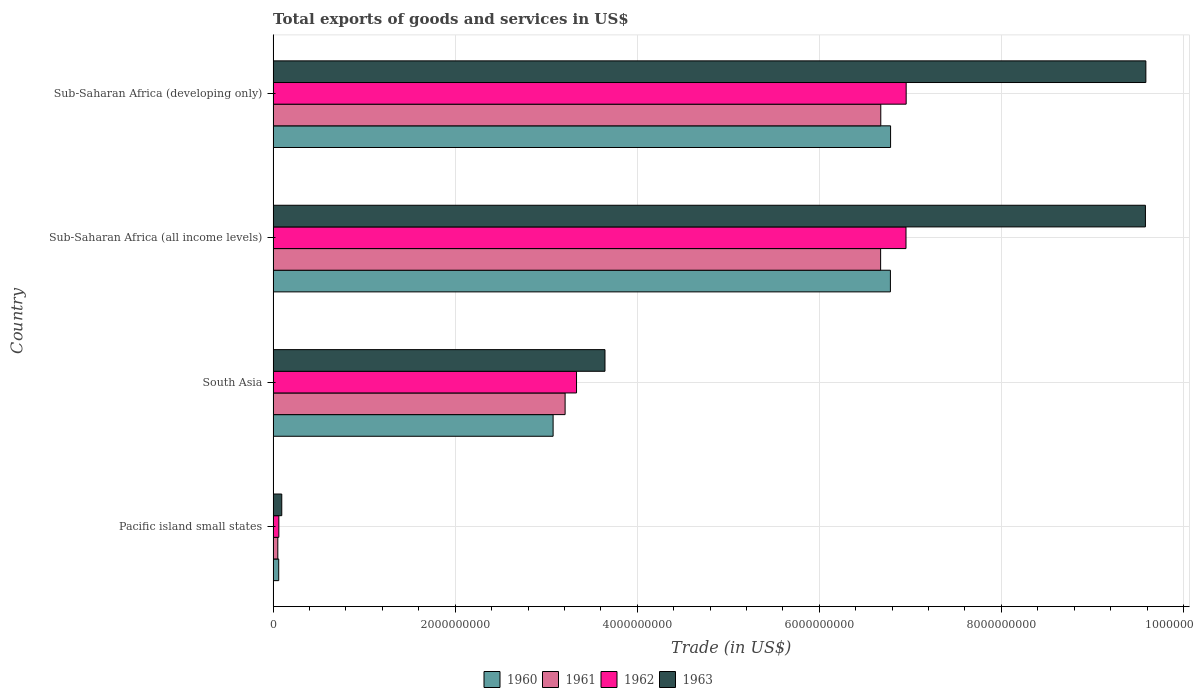How many different coloured bars are there?
Offer a terse response. 4. Are the number of bars per tick equal to the number of legend labels?
Make the answer very short. Yes. What is the label of the 1st group of bars from the top?
Provide a short and direct response. Sub-Saharan Africa (developing only). What is the total exports of goods and services in 1960 in Pacific island small states?
Offer a terse response. 6.15e+07. Across all countries, what is the maximum total exports of goods and services in 1963?
Your answer should be very brief. 9.59e+09. Across all countries, what is the minimum total exports of goods and services in 1960?
Keep it short and to the point. 6.15e+07. In which country was the total exports of goods and services in 1961 maximum?
Offer a terse response. Sub-Saharan Africa (developing only). In which country was the total exports of goods and services in 1961 minimum?
Your response must be concise. Pacific island small states. What is the total total exports of goods and services in 1960 in the graph?
Your response must be concise. 1.67e+1. What is the difference between the total exports of goods and services in 1963 in Pacific island small states and that in South Asia?
Offer a very short reply. -3.55e+09. What is the difference between the total exports of goods and services in 1963 in Pacific island small states and the total exports of goods and services in 1960 in South Asia?
Your answer should be compact. -2.98e+09. What is the average total exports of goods and services in 1962 per country?
Your response must be concise. 4.33e+09. What is the difference between the total exports of goods and services in 1960 and total exports of goods and services in 1961 in Sub-Saharan Africa (developing only)?
Your response must be concise. 1.08e+08. In how many countries, is the total exports of goods and services in 1960 greater than 2400000000 US$?
Ensure brevity in your answer.  3. What is the ratio of the total exports of goods and services in 1962 in Pacific island small states to that in Sub-Saharan Africa (all income levels)?
Keep it short and to the point. 0.01. Is the difference between the total exports of goods and services in 1960 in Pacific island small states and Sub-Saharan Africa (all income levels) greater than the difference between the total exports of goods and services in 1961 in Pacific island small states and Sub-Saharan Africa (all income levels)?
Offer a terse response. No. What is the difference between the highest and the second highest total exports of goods and services in 1961?
Give a very brief answer. 1.80e+06. What is the difference between the highest and the lowest total exports of goods and services in 1963?
Make the answer very short. 9.49e+09. Is it the case that in every country, the sum of the total exports of goods and services in 1963 and total exports of goods and services in 1962 is greater than the sum of total exports of goods and services in 1960 and total exports of goods and services in 1961?
Ensure brevity in your answer.  No. What does the 4th bar from the top in Pacific island small states represents?
Your response must be concise. 1960. What does the 4th bar from the bottom in Sub-Saharan Africa (all income levels) represents?
Provide a short and direct response. 1963. Is it the case that in every country, the sum of the total exports of goods and services in 1960 and total exports of goods and services in 1963 is greater than the total exports of goods and services in 1962?
Offer a terse response. Yes. Are all the bars in the graph horizontal?
Offer a very short reply. Yes. What is the difference between two consecutive major ticks on the X-axis?
Provide a succinct answer. 2.00e+09. Does the graph contain any zero values?
Your answer should be compact. No. Where does the legend appear in the graph?
Your answer should be compact. Bottom center. How many legend labels are there?
Offer a very short reply. 4. What is the title of the graph?
Provide a succinct answer. Total exports of goods and services in US$. Does "1992" appear as one of the legend labels in the graph?
Your answer should be very brief. No. What is the label or title of the X-axis?
Your answer should be very brief. Trade (in US$). What is the Trade (in US$) in 1960 in Pacific island small states?
Offer a terse response. 6.15e+07. What is the Trade (in US$) in 1961 in Pacific island small states?
Give a very brief answer. 5.15e+07. What is the Trade (in US$) of 1962 in Pacific island small states?
Offer a terse response. 6.29e+07. What is the Trade (in US$) in 1963 in Pacific island small states?
Your answer should be compact. 9.49e+07. What is the Trade (in US$) in 1960 in South Asia?
Make the answer very short. 3.08e+09. What is the Trade (in US$) of 1961 in South Asia?
Give a very brief answer. 3.21e+09. What is the Trade (in US$) in 1962 in South Asia?
Provide a short and direct response. 3.33e+09. What is the Trade (in US$) of 1963 in South Asia?
Offer a very short reply. 3.65e+09. What is the Trade (in US$) in 1960 in Sub-Saharan Africa (all income levels)?
Give a very brief answer. 6.78e+09. What is the Trade (in US$) in 1961 in Sub-Saharan Africa (all income levels)?
Your answer should be very brief. 6.67e+09. What is the Trade (in US$) in 1962 in Sub-Saharan Africa (all income levels)?
Provide a short and direct response. 6.95e+09. What is the Trade (in US$) of 1963 in Sub-Saharan Africa (all income levels)?
Provide a succinct answer. 9.58e+09. What is the Trade (in US$) in 1960 in Sub-Saharan Africa (developing only)?
Offer a very short reply. 6.78e+09. What is the Trade (in US$) of 1961 in Sub-Saharan Africa (developing only)?
Ensure brevity in your answer.  6.68e+09. What is the Trade (in US$) of 1962 in Sub-Saharan Africa (developing only)?
Provide a short and direct response. 6.95e+09. What is the Trade (in US$) in 1963 in Sub-Saharan Africa (developing only)?
Your response must be concise. 9.59e+09. Across all countries, what is the maximum Trade (in US$) of 1960?
Provide a short and direct response. 6.78e+09. Across all countries, what is the maximum Trade (in US$) of 1961?
Make the answer very short. 6.68e+09. Across all countries, what is the maximum Trade (in US$) of 1962?
Make the answer very short. 6.95e+09. Across all countries, what is the maximum Trade (in US$) of 1963?
Offer a very short reply. 9.59e+09. Across all countries, what is the minimum Trade (in US$) in 1960?
Keep it short and to the point. 6.15e+07. Across all countries, what is the minimum Trade (in US$) in 1961?
Give a very brief answer. 5.15e+07. Across all countries, what is the minimum Trade (in US$) of 1962?
Offer a terse response. 6.29e+07. Across all countries, what is the minimum Trade (in US$) in 1963?
Offer a very short reply. 9.49e+07. What is the total Trade (in US$) of 1960 in the graph?
Provide a short and direct response. 1.67e+1. What is the total Trade (in US$) in 1961 in the graph?
Keep it short and to the point. 1.66e+1. What is the total Trade (in US$) in 1962 in the graph?
Provide a succinct answer. 1.73e+1. What is the total Trade (in US$) in 1963 in the graph?
Provide a succinct answer. 2.29e+1. What is the difference between the Trade (in US$) of 1960 in Pacific island small states and that in South Asia?
Your answer should be very brief. -3.01e+09. What is the difference between the Trade (in US$) of 1961 in Pacific island small states and that in South Asia?
Your answer should be compact. -3.16e+09. What is the difference between the Trade (in US$) in 1962 in Pacific island small states and that in South Asia?
Your answer should be very brief. -3.27e+09. What is the difference between the Trade (in US$) in 1963 in Pacific island small states and that in South Asia?
Your answer should be very brief. -3.55e+09. What is the difference between the Trade (in US$) in 1960 in Pacific island small states and that in Sub-Saharan Africa (all income levels)?
Your answer should be very brief. -6.72e+09. What is the difference between the Trade (in US$) in 1961 in Pacific island small states and that in Sub-Saharan Africa (all income levels)?
Provide a short and direct response. -6.62e+09. What is the difference between the Trade (in US$) of 1962 in Pacific island small states and that in Sub-Saharan Africa (all income levels)?
Ensure brevity in your answer.  -6.89e+09. What is the difference between the Trade (in US$) of 1963 in Pacific island small states and that in Sub-Saharan Africa (all income levels)?
Your answer should be very brief. -9.49e+09. What is the difference between the Trade (in US$) in 1960 in Pacific island small states and that in Sub-Saharan Africa (developing only)?
Your answer should be very brief. -6.72e+09. What is the difference between the Trade (in US$) of 1961 in Pacific island small states and that in Sub-Saharan Africa (developing only)?
Your answer should be very brief. -6.62e+09. What is the difference between the Trade (in US$) in 1962 in Pacific island small states and that in Sub-Saharan Africa (developing only)?
Give a very brief answer. -6.89e+09. What is the difference between the Trade (in US$) in 1963 in Pacific island small states and that in Sub-Saharan Africa (developing only)?
Make the answer very short. -9.49e+09. What is the difference between the Trade (in US$) of 1960 in South Asia and that in Sub-Saharan Africa (all income levels)?
Your response must be concise. -3.71e+09. What is the difference between the Trade (in US$) of 1961 in South Asia and that in Sub-Saharan Africa (all income levels)?
Provide a succinct answer. -3.47e+09. What is the difference between the Trade (in US$) in 1962 in South Asia and that in Sub-Saharan Africa (all income levels)?
Ensure brevity in your answer.  -3.62e+09. What is the difference between the Trade (in US$) of 1963 in South Asia and that in Sub-Saharan Africa (all income levels)?
Give a very brief answer. -5.94e+09. What is the difference between the Trade (in US$) in 1960 in South Asia and that in Sub-Saharan Africa (developing only)?
Ensure brevity in your answer.  -3.71e+09. What is the difference between the Trade (in US$) of 1961 in South Asia and that in Sub-Saharan Africa (developing only)?
Provide a short and direct response. -3.47e+09. What is the difference between the Trade (in US$) of 1962 in South Asia and that in Sub-Saharan Africa (developing only)?
Offer a terse response. -3.62e+09. What is the difference between the Trade (in US$) of 1963 in South Asia and that in Sub-Saharan Africa (developing only)?
Keep it short and to the point. -5.94e+09. What is the difference between the Trade (in US$) in 1960 in Sub-Saharan Africa (all income levels) and that in Sub-Saharan Africa (developing only)?
Keep it short and to the point. -1.83e+06. What is the difference between the Trade (in US$) in 1961 in Sub-Saharan Africa (all income levels) and that in Sub-Saharan Africa (developing only)?
Offer a very short reply. -1.80e+06. What is the difference between the Trade (in US$) of 1962 in Sub-Saharan Africa (all income levels) and that in Sub-Saharan Africa (developing only)?
Ensure brevity in your answer.  -1.87e+06. What is the difference between the Trade (in US$) in 1963 in Sub-Saharan Africa (all income levels) and that in Sub-Saharan Africa (developing only)?
Your answer should be very brief. -4.80e+06. What is the difference between the Trade (in US$) of 1960 in Pacific island small states and the Trade (in US$) of 1961 in South Asia?
Provide a short and direct response. -3.15e+09. What is the difference between the Trade (in US$) in 1960 in Pacific island small states and the Trade (in US$) in 1962 in South Asia?
Offer a terse response. -3.27e+09. What is the difference between the Trade (in US$) in 1960 in Pacific island small states and the Trade (in US$) in 1963 in South Asia?
Your answer should be compact. -3.58e+09. What is the difference between the Trade (in US$) of 1961 in Pacific island small states and the Trade (in US$) of 1962 in South Asia?
Provide a short and direct response. -3.28e+09. What is the difference between the Trade (in US$) of 1961 in Pacific island small states and the Trade (in US$) of 1963 in South Asia?
Provide a short and direct response. -3.59e+09. What is the difference between the Trade (in US$) in 1962 in Pacific island small states and the Trade (in US$) in 1963 in South Asia?
Your answer should be very brief. -3.58e+09. What is the difference between the Trade (in US$) of 1960 in Pacific island small states and the Trade (in US$) of 1961 in Sub-Saharan Africa (all income levels)?
Provide a short and direct response. -6.61e+09. What is the difference between the Trade (in US$) in 1960 in Pacific island small states and the Trade (in US$) in 1962 in Sub-Saharan Africa (all income levels)?
Your answer should be very brief. -6.89e+09. What is the difference between the Trade (in US$) in 1960 in Pacific island small states and the Trade (in US$) in 1963 in Sub-Saharan Africa (all income levels)?
Ensure brevity in your answer.  -9.52e+09. What is the difference between the Trade (in US$) in 1961 in Pacific island small states and the Trade (in US$) in 1962 in Sub-Saharan Africa (all income levels)?
Offer a terse response. -6.90e+09. What is the difference between the Trade (in US$) in 1961 in Pacific island small states and the Trade (in US$) in 1963 in Sub-Saharan Africa (all income levels)?
Offer a very short reply. -9.53e+09. What is the difference between the Trade (in US$) in 1962 in Pacific island small states and the Trade (in US$) in 1963 in Sub-Saharan Africa (all income levels)?
Your answer should be compact. -9.52e+09. What is the difference between the Trade (in US$) in 1960 in Pacific island small states and the Trade (in US$) in 1961 in Sub-Saharan Africa (developing only)?
Keep it short and to the point. -6.61e+09. What is the difference between the Trade (in US$) in 1960 in Pacific island small states and the Trade (in US$) in 1962 in Sub-Saharan Africa (developing only)?
Give a very brief answer. -6.89e+09. What is the difference between the Trade (in US$) of 1960 in Pacific island small states and the Trade (in US$) of 1963 in Sub-Saharan Africa (developing only)?
Make the answer very short. -9.53e+09. What is the difference between the Trade (in US$) in 1961 in Pacific island small states and the Trade (in US$) in 1962 in Sub-Saharan Africa (developing only)?
Provide a succinct answer. -6.90e+09. What is the difference between the Trade (in US$) in 1961 in Pacific island small states and the Trade (in US$) in 1963 in Sub-Saharan Africa (developing only)?
Your response must be concise. -9.54e+09. What is the difference between the Trade (in US$) of 1962 in Pacific island small states and the Trade (in US$) of 1963 in Sub-Saharan Africa (developing only)?
Offer a terse response. -9.52e+09. What is the difference between the Trade (in US$) of 1960 in South Asia and the Trade (in US$) of 1961 in Sub-Saharan Africa (all income levels)?
Ensure brevity in your answer.  -3.60e+09. What is the difference between the Trade (in US$) in 1960 in South Asia and the Trade (in US$) in 1962 in Sub-Saharan Africa (all income levels)?
Ensure brevity in your answer.  -3.88e+09. What is the difference between the Trade (in US$) of 1960 in South Asia and the Trade (in US$) of 1963 in Sub-Saharan Africa (all income levels)?
Provide a succinct answer. -6.51e+09. What is the difference between the Trade (in US$) of 1961 in South Asia and the Trade (in US$) of 1962 in Sub-Saharan Africa (all income levels)?
Make the answer very short. -3.74e+09. What is the difference between the Trade (in US$) in 1961 in South Asia and the Trade (in US$) in 1963 in Sub-Saharan Africa (all income levels)?
Keep it short and to the point. -6.37e+09. What is the difference between the Trade (in US$) in 1962 in South Asia and the Trade (in US$) in 1963 in Sub-Saharan Africa (all income levels)?
Provide a short and direct response. -6.25e+09. What is the difference between the Trade (in US$) of 1960 in South Asia and the Trade (in US$) of 1961 in Sub-Saharan Africa (developing only)?
Provide a succinct answer. -3.60e+09. What is the difference between the Trade (in US$) in 1960 in South Asia and the Trade (in US$) in 1962 in Sub-Saharan Africa (developing only)?
Make the answer very short. -3.88e+09. What is the difference between the Trade (in US$) of 1960 in South Asia and the Trade (in US$) of 1963 in Sub-Saharan Africa (developing only)?
Ensure brevity in your answer.  -6.51e+09. What is the difference between the Trade (in US$) of 1961 in South Asia and the Trade (in US$) of 1962 in Sub-Saharan Africa (developing only)?
Provide a succinct answer. -3.75e+09. What is the difference between the Trade (in US$) in 1961 in South Asia and the Trade (in US$) in 1963 in Sub-Saharan Africa (developing only)?
Ensure brevity in your answer.  -6.38e+09. What is the difference between the Trade (in US$) in 1962 in South Asia and the Trade (in US$) in 1963 in Sub-Saharan Africa (developing only)?
Offer a very short reply. -6.25e+09. What is the difference between the Trade (in US$) in 1960 in Sub-Saharan Africa (all income levels) and the Trade (in US$) in 1961 in Sub-Saharan Africa (developing only)?
Your answer should be very brief. 1.06e+08. What is the difference between the Trade (in US$) of 1960 in Sub-Saharan Africa (all income levels) and the Trade (in US$) of 1962 in Sub-Saharan Africa (developing only)?
Your response must be concise. -1.73e+08. What is the difference between the Trade (in US$) in 1960 in Sub-Saharan Africa (all income levels) and the Trade (in US$) in 1963 in Sub-Saharan Africa (developing only)?
Your answer should be very brief. -2.81e+09. What is the difference between the Trade (in US$) in 1961 in Sub-Saharan Africa (all income levels) and the Trade (in US$) in 1962 in Sub-Saharan Africa (developing only)?
Offer a very short reply. -2.81e+08. What is the difference between the Trade (in US$) of 1961 in Sub-Saharan Africa (all income levels) and the Trade (in US$) of 1963 in Sub-Saharan Africa (developing only)?
Keep it short and to the point. -2.91e+09. What is the difference between the Trade (in US$) in 1962 in Sub-Saharan Africa (all income levels) and the Trade (in US$) in 1963 in Sub-Saharan Africa (developing only)?
Offer a very short reply. -2.63e+09. What is the average Trade (in US$) of 1960 per country?
Offer a very short reply. 4.18e+09. What is the average Trade (in US$) of 1961 per country?
Give a very brief answer. 4.15e+09. What is the average Trade (in US$) of 1962 per country?
Give a very brief answer. 4.33e+09. What is the average Trade (in US$) in 1963 per country?
Make the answer very short. 5.73e+09. What is the difference between the Trade (in US$) of 1960 and Trade (in US$) of 1961 in Pacific island small states?
Offer a terse response. 9.94e+06. What is the difference between the Trade (in US$) of 1960 and Trade (in US$) of 1962 in Pacific island small states?
Your answer should be very brief. -1.45e+06. What is the difference between the Trade (in US$) of 1960 and Trade (in US$) of 1963 in Pacific island small states?
Provide a short and direct response. -3.35e+07. What is the difference between the Trade (in US$) in 1961 and Trade (in US$) in 1962 in Pacific island small states?
Make the answer very short. -1.14e+07. What is the difference between the Trade (in US$) in 1961 and Trade (in US$) in 1963 in Pacific island small states?
Your answer should be compact. -4.34e+07. What is the difference between the Trade (in US$) in 1962 and Trade (in US$) in 1963 in Pacific island small states?
Make the answer very short. -3.20e+07. What is the difference between the Trade (in US$) in 1960 and Trade (in US$) in 1961 in South Asia?
Provide a short and direct response. -1.32e+08. What is the difference between the Trade (in US$) of 1960 and Trade (in US$) of 1962 in South Asia?
Your answer should be very brief. -2.57e+08. What is the difference between the Trade (in US$) of 1960 and Trade (in US$) of 1963 in South Asia?
Ensure brevity in your answer.  -5.70e+08. What is the difference between the Trade (in US$) in 1961 and Trade (in US$) in 1962 in South Asia?
Your answer should be very brief. -1.26e+08. What is the difference between the Trade (in US$) of 1961 and Trade (in US$) of 1963 in South Asia?
Your answer should be very brief. -4.38e+08. What is the difference between the Trade (in US$) of 1962 and Trade (in US$) of 1963 in South Asia?
Keep it short and to the point. -3.13e+08. What is the difference between the Trade (in US$) in 1960 and Trade (in US$) in 1961 in Sub-Saharan Africa (all income levels)?
Make the answer very short. 1.08e+08. What is the difference between the Trade (in US$) in 1960 and Trade (in US$) in 1962 in Sub-Saharan Africa (all income levels)?
Offer a very short reply. -1.71e+08. What is the difference between the Trade (in US$) in 1960 and Trade (in US$) in 1963 in Sub-Saharan Africa (all income levels)?
Your answer should be compact. -2.80e+09. What is the difference between the Trade (in US$) of 1961 and Trade (in US$) of 1962 in Sub-Saharan Africa (all income levels)?
Offer a very short reply. -2.79e+08. What is the difference between the Trade (in US$) of 1961 and Trade (in US$) of 1963 in Sub-Saharan Africa (all income levels)?
Ensure brevity in your answer.  -2.91e+09. What is the difference between the Trade (in US$) of 1962 and Trade (in US$) of 1963 in Sub-Saharan Africa (all income levels)?
Your answer should be very brief. -2.63e+09. What is the difference between the Trade (in US$) of 1960 and Trade (in US$) of 1961 in Sub-Saharan Africa (developing only)?
Provide a succinct answer. 1.08e+08. What is the difference between the Trade (in US$) in 1960 and Trade (in US$) in 1962 in Sub-Saharan Africa (developing only)?
Your answer should be very brief. -1.71e+08. What is the difference between the Trade (in US$) of 1960 and Trade (in US$) of 1963 in Sub-Saharan Africa (developing only)?
Keep it short and to the point. -2.80e+09. What is the difference between the Trade (in US$) in 1961 and Trade (in US$) in 1962 in Sub-Saharan Africa (developing only)?
Your answer should be very brief. -2.79e+08. What is the difference between the Trade (in US$) in 1961 and Trade (in US$) in 1963 in Sub-Saharan Africa (developing only)?
Keep it short and to the point. -2.91e+09. What is the difference between the Trade (in US$) in 1962 and Trade (in US$) in 1963 in Sub-Saharan Africa (developing only)?
Your answer should be compact. -2.63e+09. What is the ratio of the Trade (in US$) in 1960 in Pacific island small states to that in South Asia?
Make the answer very short. 0.02. What is the ratio of the Trade (in US$) in 1961 in Pacific island small states to that in South Asia?
Make the answer very short. 0.02. What is the ratio of the Trade (in US$) of 1962 in Pacific island small states to that in South Asia?
Ensure brevity in your answer.  0.02. What is the ratio of the Trade (in US$) in 1963 in Pacific island small states to that in South Asia?
Your answer should be very brief. 0.03. What is the ratio of the Trade (in US$) in 1960 in Pacific island small states to that in Sub-Saharan Africa (all income levels)?
Offer a terse response. 0.01. What is the ratio of the Trade (in US$) in 1961 in Pacific island small states to that in Sub-Saharan Africa (all income levels)?
Keep it short and to the point. 0.01. What is the ratio of the Trade (in US$) in 1962 in Pacific island small states to that in Sub-Saharan Africa (all income levels)?
Provide a short and direct response. 0.01. What is the ratio of the Trade (in US$) of 1963 in Pacific island small states to that in Sub-Saharan Africa (all income levels)?
Offer a very short reply. 0.01. What is the ratio of the Trade (in US$) of 1960 in Pacific island small states to that in Sub-Saharan Africa (developing only)?
Offer a terse response. 0.01. What is the ratio of the Trade (in US$) in 1961 in Pacific island small states to that in Sub-Saharan Africa (developing only)?
Your response must be concise. 0.01. What is the ratio of the Trade (in US$) in 1962 in Pacific island small states to that in Sub-Saharan Africa (developing only)?
Offer a very short reply. 0.01. What is the ratio of the Trade (in US$) in 1963 in Pacific island small states to that in Sub-Saharan Africa (developing only)?
Provide a succinct answer. 0.01. What is the ratio of the Trade (in US$) in 1960 in South Asia to that in Sub-Saharan Africa (all income levels)?
Keep it short and to the point. 0.45. What is the ratio of the Trade (in US$) of 1961 in South Asia to that in Sub-Saharan Africa (all income levels)?
Your answer should be very brief. 0.48. What is the ratio of the Trade (in US$) of 1962 in South Asia to that in Sub-Saharan Africa (all income levels)?
Provide a succinct answer. 0.48. What is the ratio of the Trade (in US$) of 1963 in South Asia to that in Sub-Saharan Africa (all income levels)?
Your answer should be very brief. 0.38. What is the ratio of the Trade (in US$) in 1960 in South Asia to that in Sub-Saharan Africa (developing only)?
Ensure brevity in your answer.  0.45. What is the ratio of the Trade (in US$) of 1961 in South Asia to that in Sub-Saharan Africa (developing only)?
Provide a short and direct response. 0.48. What is the ratio of the Trade (in US$) in 1962 in South Asia to that in Sub-Saharan Africa (developing only)?
Offer a terse response. 0.48. What is the ratio of the Trade (in US$) in 1963 in South Asia to that in Sub-Saharan Africa (developing only)?
Your response must be concise. 0.38. What is the ratio of the Trade (in US$) of 1960 in Sub-Saharan Africa (all income levels) to that in Sub-Saharan Africa (developing only)?
Your response must be concise. 1. What is the ratio of the Trade (in US$) of 1962 in Sub-Saharan Africa (all income levels) to that in Sub-Saharan Africa (developing only)?
Your response must be concise. 1. What is the difference between the highest and the second highest Trade (in US$) in 1960?
Your response must be concise. 1.83e+06. What is the difference between the highest and the second highest Trade (in US$) in 1961?
Offer a terse response. 1.80e+06. What is the difference between the highest and the second highest Trade (in US$) in 1962?
Offer a very short reply. 1.87e+06. What is the difference between the highest and the second highest Trade (in US$) of 1963?
Offer a terse response. 4.80e+06. What is the difference between the highest and the lowest Trade (in US$) in 1960?
Make the answer very short. 6.72e+09. What is the difference between the highest and the lowest Trade (in US$) of 1961?
Your answer should be very brief. 6.62e+09. What is the difference between the highest and the lowest Trade (in US$) of 1962?
Your answer should be compact. 6.89e+09. What is the difference between the highest and the lowest Trade (in US$) in 1963?
Provide a short and direct response. 9.49e+09. 